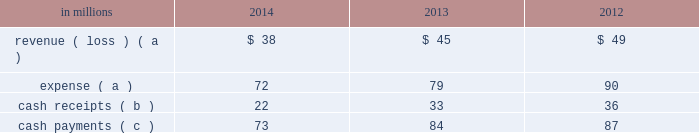Also during 2006 , the entities acquired approximately $ 4.8 billion of international paper debt obligations for cash , resulting in a total of approximately $ 5.2 billion of international paper debt obligations held by the entities at december 31 , 2006 .
The various agreements entered into in connection with these transactions provide that international paper has , and intends to effect , a legal right to offset its obligation under these debt instruments with its investments in the entities .
Accordingly , for financial reporting purposes , international paper has offset approximately $ 5.2 billion of class b interests in the entities against $ 5.3 billion of international paper debt obligations held by these entities at december 31 , 2014 and 2013 .
Despite the offset treatment , these remain debt obligations of international paper .
Remaining borrowings of $ 50 million and $ 67 million at december 31 , 2014 and 2013 , respectively , are included in floating rate notes due 2014 2013 2019 in the summary of long-term debt in note 13 .
Additional debt related to the above transaction of $ 107 million and $ 79 million is included in short-term notes in the summary of long-term debt in note 13 at december 31 , 2014 and 2013 .
The use of the above entities facilitated the monetization of the credit enhanced timber notes in a cost effective manner by increasing the borrowing capacity and lowering the interest rate , while providing for the offset accounting treatment described above .
Additionally , the monetization structure preserved the tax deferral that resulted from the 2006 forestlands sales .
The company recognized a $ 1.4 billion deferred tax liability in connection with the 2006 forestlands sale , which will be settled with the maturity of the timber notes in the third quarter of 2016 ( unless extended ) .
During 2011 and 2012 , the credit ratings for two letter of credit banks that support $ 1.5 billion of timber notes were downgraded below the specified threshold .
These letters of credit were successfully replaced by other qualifying institutions .
Fees of $ 10 million were incurred during 2012 in connection with these replacements .
During 2012 , an additional letter of credit bank that supports $ 707 million of timber notes was downgraded below the specified threshold .
In december 2012 , the company and the third-party managing member agreed to a continuing replacement waiver for these letters of credit , terminable upon 30 days notice .
Activity between the company and the entities was as follows: .
( a ) the net expense related to the company 2019s interest in the entities is included in interest expense , net in the accompanying consolidated statement of operations , as international paper has and intends to effect its legal right to offset as discussed above .
( b ) the cash receipts are equity distributions from the entities to international paper .
( c ) the semi-annual payments are related to interest on the associated debt obligations discussed above .
Based on an analysis of the entities discussed above under guidance that considers the potential magnitude of the variability in the structures and which party has a controlling financial interest , international paper determined that it is not the primary beneficiary of the entities , and therefore , should not consolidate its investments in these entities .
It was also determined that the source of variability in the structure is the value of the timber notes , the assets most significantly impacting the structure 2019s economic performance .
The credit quality of the timber notes is supported by irrevocable letters of credit obtained by third-party buyers which are 100% ( 100 % ) cash collateralized .
International paper analyzed which party has control over the economic performance of each entity , and concluded international paper does not have control over significant decisions surrounding the timber notes and letters of credit and therefore is not the primary beneficiary .
The company 2019s maximum exposure to loss equals the value of the timber notes ; however , an analysis performed by the company concluded the likelihood of this exposure is remote .
International paper also held variable interests in financing entities that were used to monetize long-term notes received from the sale of forestlands in 2002 .
International paper transferred notes ( the monetized notes , with an original maturity of 10 years from inception ) and cash of approximately $ 500 million to these entities in exchange for preferred interests , and accounted for the transfers as a sale of the notes with no associated gain or loss .
In the same period , the entities acquired approximately $ 500 million of international paper debt obligations for cash .
International paper has no obligation to make any further capital contributions to these entities and did not provide any financial support that was not previously contractually required during the years ended december 31 , 2014 , 2013 or 2012 .
During 2012 , $ 252 million of the 2002 monetized notes matured .
Cash receipts upon maturity were used to pay the associated debt obligations .
Effective june 1 , 2012 , international paper liquidated its interest in the 2002 financing entities .
In connection with the acquisition of temple-inland in february 2012 , two special purpose entities became wholly-owned subsidiaries of international paper. .
What was the initial debt obligations balance in 2006 prior to the additional sales of international paper debt obligations for cash in billions? 
Computations: (5.2 - 4.8)
Answer: 0.4. 